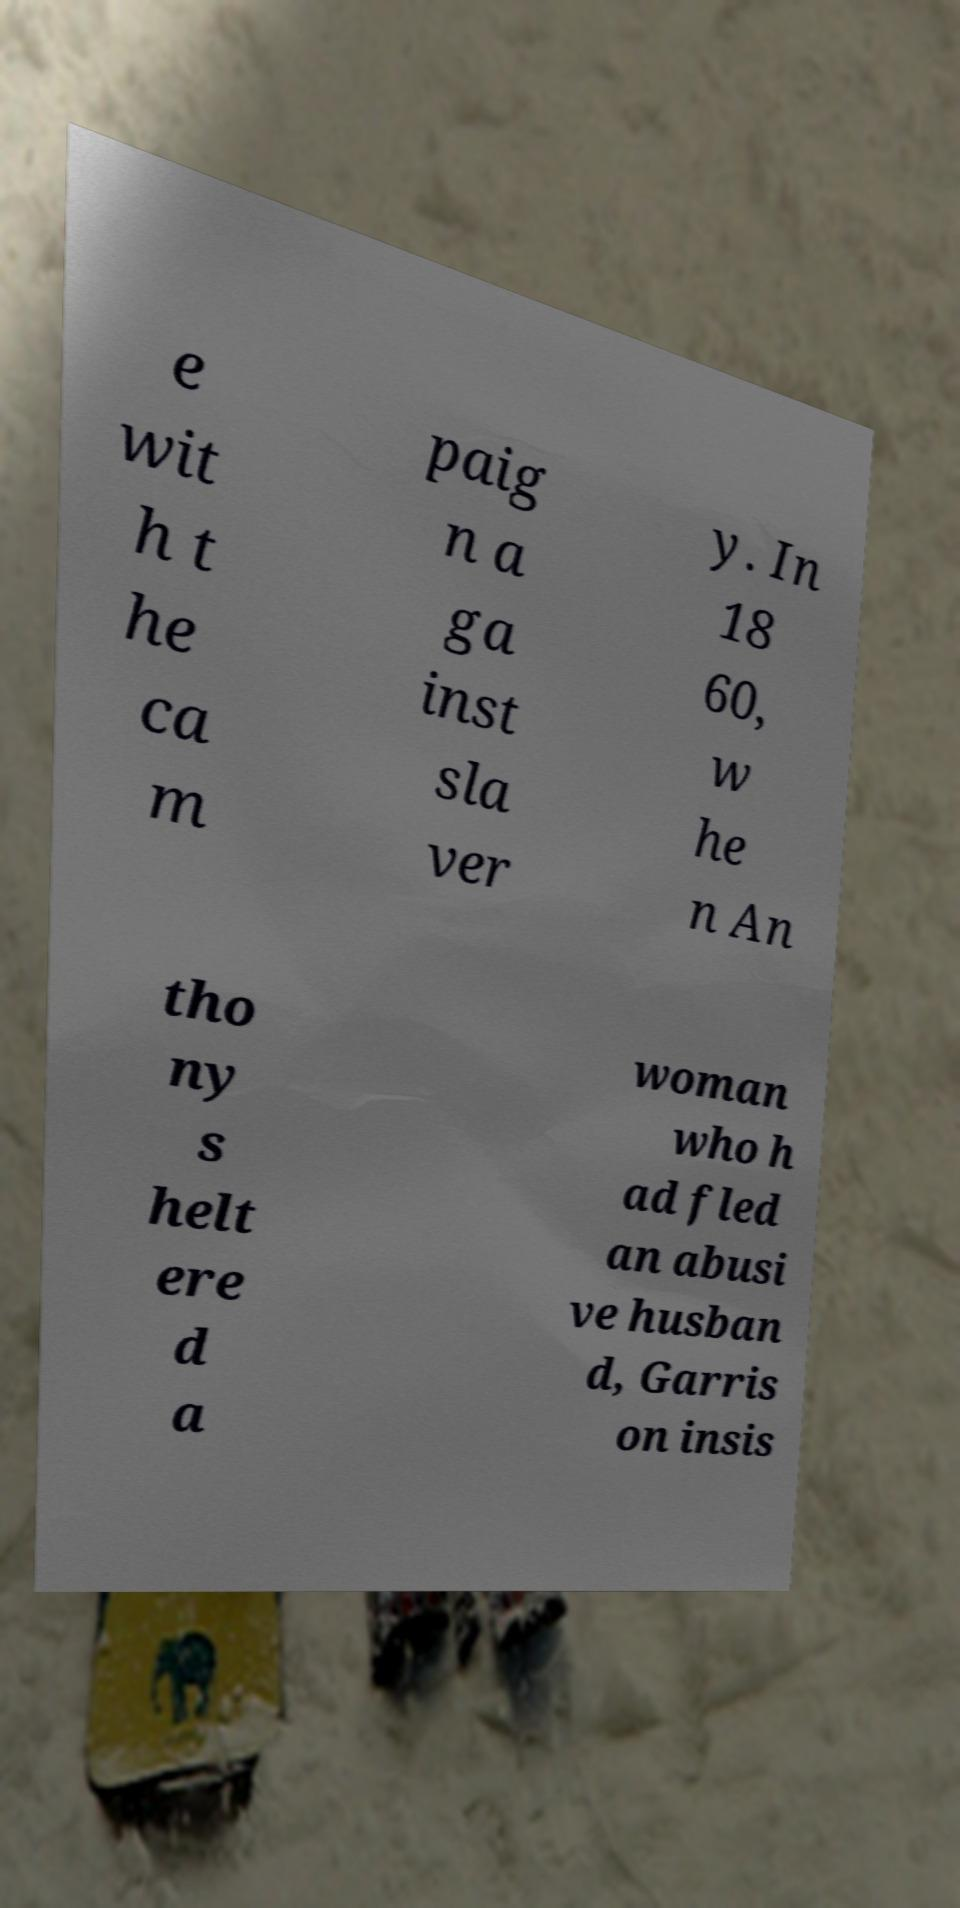What messages or text are displayed in this image? I need them in a readable, typed format. e wit h t he ca m paig n a ga inst sla ver y. In 18 60, w he n An tho ny s helt ere d a woman who h ad fled an abusi ve husban d, Garris on insis 